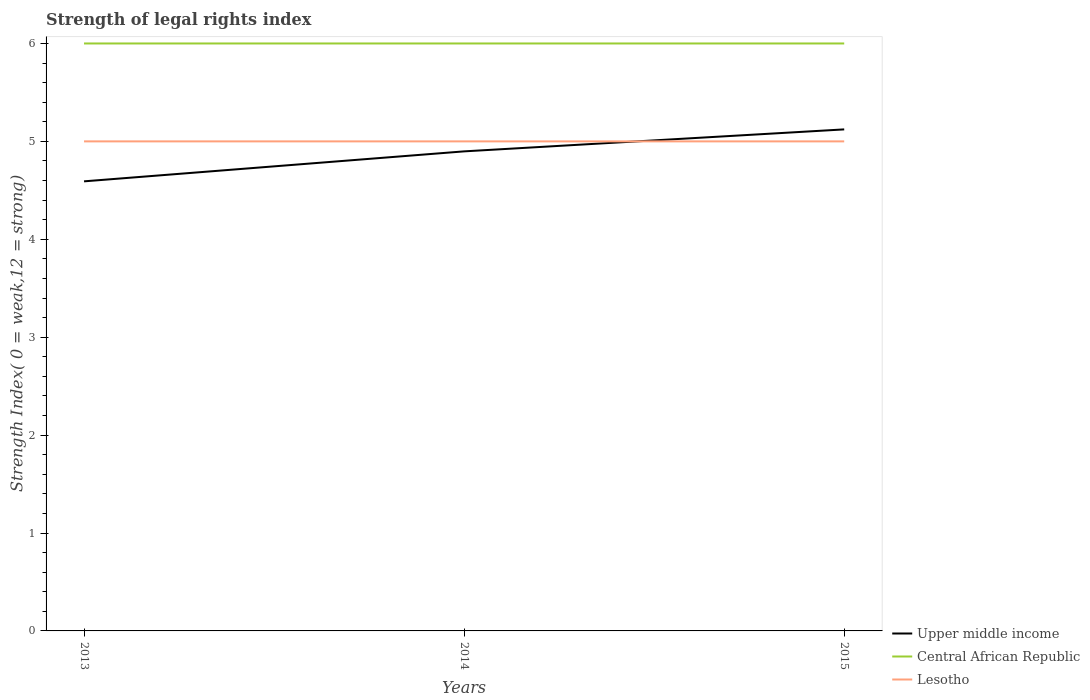Across all years, what is the maximum strength index in Central African Republic?
Your answer should be very brief. 6. How many years are there in the graph?
Provide a succinct answer. 3. Does the graph contain any zero values?
Keep it short and to the point. No. How are the legend labels stacked?
Offer a very short reply. Vertical. What is the title of the graph?
Make the answer very short. Strength of legal rights index. Does "European Union" appear as one of the legend labels in the graph?
Provide a succinct answer. No. What is the label or title of the X-axis?
Provide a short and direct response. Years. What is the label or title of the Y-axis?
Make the answer very short. Strength Index( 0 = weak,12 = strong). What is the Strength Index( 0 = weak,12 = strong) of Upper middle income in 2013?
Provide a short and direct response. 4.59. What is the Strength Index( 0 = weak,12 = strong) of Central African Republic in 2013?
Offer a very short reply. 6. What is the Strength Index( 0 = weak,12 = strong) of Lesotho in 2013?
Keep it short and to the point. 5. What is the Strength Index( 0 = weak,12 = strong) of Upper middle income in 2014?
Offer a very short reply. 4.9. What is the Strength Index( 0 = weak,12 = strong) in Lesotho in 2014?
Your answer should be very brief. 5. What is the Strength Index( 0 = weak,12 = strong) in Upper middle income in 2015?
Your answer should be very brief. 5.12. What is the Strength Index( 0 = weak,12 = strong) in Central African Republic in 2015?
Your answer should be compact. 6. Across all years, what is the maximum Strength Index( 0 = weak,12 = strong) of Upper middle income?
Ensure brevity in your answer.  5.12. Across all years, what is the maximum Strength Index( 0 = weak,12 = strong) in Central African Republic?
Provide a succinct answer. 6. Across all years, what is the maximum Strength Index( 0 = weak,12 = strong) of Lesotho?
Make the answer very short. 5. Across all years, what is the minimum Strength Index( 0 = weak,12 = strong) in Upper middle income?
Ensure brevity in your answer.  4.59. Across all years, what is the minimum Strength Index( 0 = weak,12 = strong) of Central African Republic?
Ensure brevity in your answer.  6. Across all years, what is the minimum Strength Index( 0 = weak,12 = strong) in Lesotho?
Make the answer very short. 5. What is the total Strength Index( 0 = weak,12 = strong) of Upper middle income in the graph?
Provide a succinct answer. 14.61. What is the total Strength Index( 0 = weak,12 = strong) in Lesotho in the graph?
Offer a very short reply. 15. What is the difference between the Strength Index( 0 = weak,12 = strong) of Upper middle income in 2013 and that in 2014?
Your answer should be compact. -0.31. What is the difference between the Strength Index( 0 = weak,12 = strong) in Upper middle income in 2013 and that in 2015?
Offer a very short reply. -0.53. What is the difference between the Strength Index( 0 = weak,12 = strong) in Lesotho in 2013 and that in 2015?
Keep it short and to the point. 0. What is the difference between the Strength Index( 0 = weak,12 = strong) in Upper middle income in 2014 and that in 2015?
Your answer should be compact. -0.22. What is the difference between the Strength Index( 0 = weak,12 = strong) of Lesotho in 2014 and that in 2015?
Ensure brevity in your answer.  0. What is the difference between the Strength Index( 0 = weak,12 = strong) in Upper middle income in 2013 and the Strength Index( 0 = weak,12 = strong) in Central African Republic in 2014?
Give a very brief answer. -1.41. What is the difference between the Strength Index( 0 = weak,12 = strong) in Upper middle income in 2013 and the Strength Index( 0 = weak,12 = strong) in Lesotho in 2014?
Ensure brevity in your answer.  -0.41. What is the difference between the Strength Index( 0 = weak,12 = strong) in Central African Republic in 2013 and the Strength Index( 0 = weak,12 = strong) in Lesotho in 2014?
Your response must be concise. 1. What is the difference between the Strength Index( 0 = weak,12 = strong) of Upper middle income in 2013 and the Strength Index( 0 = weak,12 = strong) of Central African Republic in 2015?
Make the answer very short. -1.41. What is the difference between the Strength Index( 0 = weak,12 = strong) in Upper middle income in 2013 and the Strength Index( 0 = weak,12 = strong) in Lesotho in 2015?
Offer a very short reply. -0.41. What is the difference between the Strength Index( 0 = weak,12 = strong) of Central African Republic in 2013 and the Strength Index( 0 = weak,12 = strong) of Lesotho in 2015?
Give a very brief answer. 1. What is the difference between the Strength Index( 0 = weak,12 = strong) in Upper middle income in 2014 and the Strength Index( 0 = weak,12 = strong) in Central African Republic in 2015?
Provide a short and direct response. -1.1. What is the difference between the Strength Index( 0 = weak,12 = strong) of Upper middle income in 2014 and the Strength Index( 0 = weak,12 = strong) of Lesotho in 2015?
Ensure brevity in your answer.  -0.1. What is the average Strength Index( 0 = weak,12 = strong) of Upper middle income per year?
Make the answer very short. 4.87. What is the average Strength Index( 0 = weak,12 = strong) of Central African Republic per year?
Your answer should be very brief. 6. In the year 2013, what is the difference between the Strength Index( 0 = weak,12 = strong) of Upper middle income and Strength Index( 0 = weak,12 = strong) of Central African Republic?
Your response must be concise. -1.41. In the year 2013, what is the difference between the Strength Index( 0 = weak,12 = strong) of Upper middle income and Strength Index( 0 = weak,12 = strong) of Lesotho?
Keep it short and to the point. -0.41. In the year 2014, what is the difference between the Strength Index( 0 = weak,12 = strong) in Upper middle income and Strength Index( 0 = weak,12 = strong) in Central African Republic?
Offer a very short reply. -1.1. In the year 2014, what is the difference between the Strength Index( 0 = weak,12 = strong) of Upper middle income and Strength Index( 0 = weak,12 = strong) of Lesotho?
Make the answer very short. -0.1. In the year 2014, what is the difference between the Strength Index( 0 = weak,12 = strong) in Central African Republic and Strength Index( 0 = weak,12 = strong) in Lesotho?
Provide a succinct answer. 1. In the year 2015, what is the difference between the Strength Index( 0 = weak,12 = strong) in Upper middle income and Strength Index( 0 = weak,12 = strong) in Central African Republic?
Make the answer very short. -0.88. In the year 2015, what is the difference between the Strength Index( 0 = weak,12 = strong) in Upper middle income and Strength Index( 0 = weak,12 = strong) in Lesotho?
Your response must be concise. 0.12. In the year 2015, what is the difference between the Strength Index( 0 = weak,12 = strong) of Central African Republic and Strength Index( 0 = weak,12 = strong) of Lesotho?
Make the answer very short. 1. What is the ratio of the Strength Index( 0 = weak,12 = strong) of Lesotho in 2013 to that in 2014?
Make the answer very short. 1. What is the ratio of the Strength Index( 0 = weak,12 = strong) in Upper middle income in 2013 to that in 2015?
Ensure brevity in your answer.  0.9. What is the ratio of the Strength Index( 0 = weak,12 = strong) of Central African Republic in 2013 to that in 2015?
Your response must be concise. 1. What is the ratio of the Strength Index( 0 = weak,12 = strong) of Upper middle income in 2014 to that in 2015?
Your answer should be very brief. 0.96. What is the ratio of the Strength Index( 0 = weak,12 = strong) in Central African Republic in 2014 to that in 2015?
Make the answer very short. 1. What is the ratio of the Strength Index( 0 = weak,12 = strong) in Lesotho in 2014 to that in 2015?
Your answer should be compact. 1. What is the difference between the highest and the second highest Strength Index( 0 = weak,12 = strong) of Upper middle income?
Offer a very short reply. 0.22. What is the difference between the highest and the lowest Strength Index( 0 = weak,12 = strong) in Upper middle income?
Give a very brief answer. 0.53. What is the difference between the highest and the lowest Strength Index( 0 = weak,12 = strong) of Lesotho?
Make the answer very short. 0. 